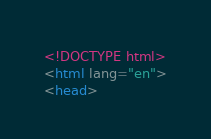<code> <loc_0><loc_0><loc_500><loc_500><_HTML_><!DOCTYPE html>
<html lang="en">
<head></code> 